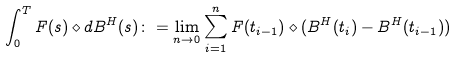Convert formula to latex. <formula><loc_0><loc_0><loc_500><loc_500>\int _ { 0 } ^ { T } F ( s ) \diamond d B ^ { H } ( s ) \colon = \lim _ { n \rightarrow 0 } \sum _ { i = 1 } ^ { n } F ( t _ { i - 1 } ) \diamond ( B ^ { H } ( t _ { i } ) - B ^ { H } ( t _ { i - 1 } ) )</formula> 